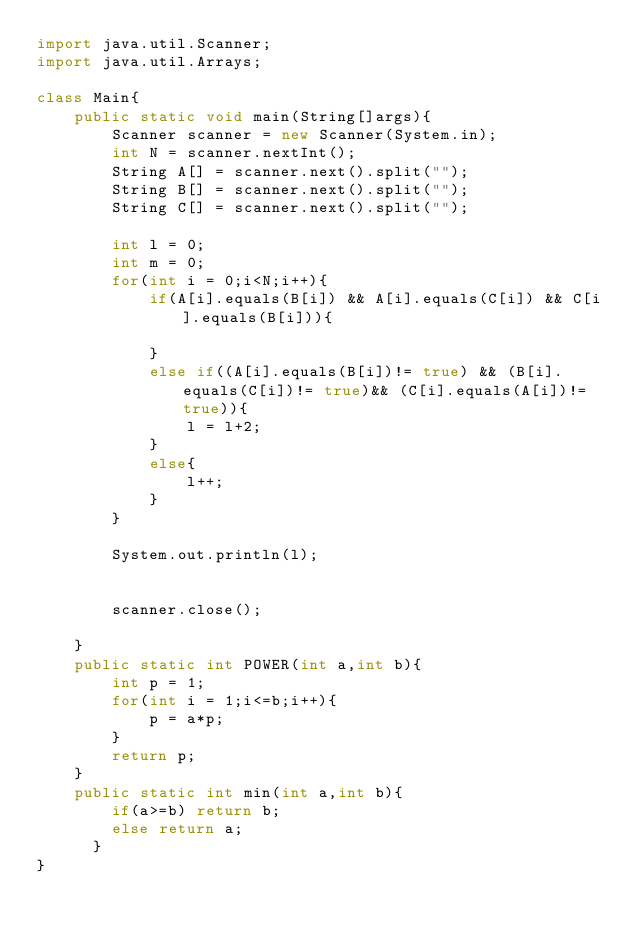Convert code to text. <code><loc_0><loc_0><loc_500><loc_500><_Java_>import java.util.Scanner;
import java.util.Arrays;

class Main{
    public static void main(String[]args){
        Scanner scanner = new Scanner(System.in);
        int N = scanner.nextInt();
        String A[] = scanner.next().split("");
        String B[] = scanner.next().split("");
        String C[] = scanner.next().split("");
        
        int l = 0;
        int m = 0;
        for(int i = 0;i<N;i++){
            if(A[i].equals(B[i]) && A[i].equals(C[i]) && C[i].equals(B[i])){
                
            }
            else if((A[i].equals(B[i])!= true) && (B[i].equals(C[i])!= true)&& (C[i].equals(A[i])!= true)){
                l = l+2;
            }
            else{
                l++;
            }
        }

        System.out.println(l);
        
        
        scanner.close();

    }
    public static int POWER(int a,int b){
        int p = 1;
        for(int i = 1;i<=b;i++){
            p = a*p;
        }
        return p;
    }
    public static int min(int a,int b){
        if(a>=b) return b;
        else return a;
      }
}</code> 